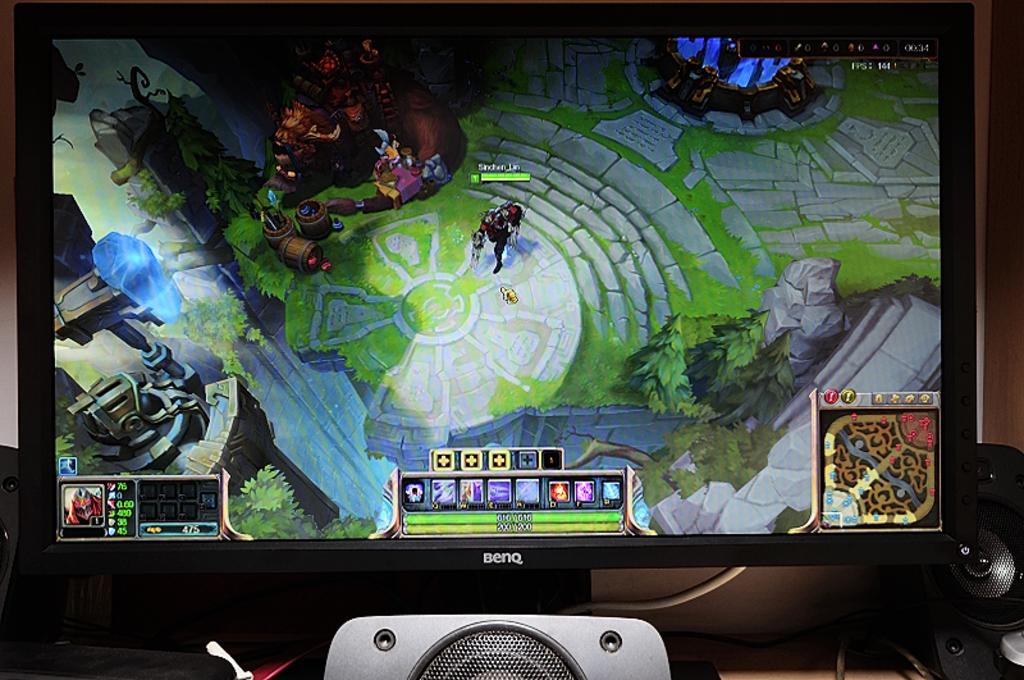<image>
Present a compact description of the photo's key features. a Benq video screen has a video game mid play on it 